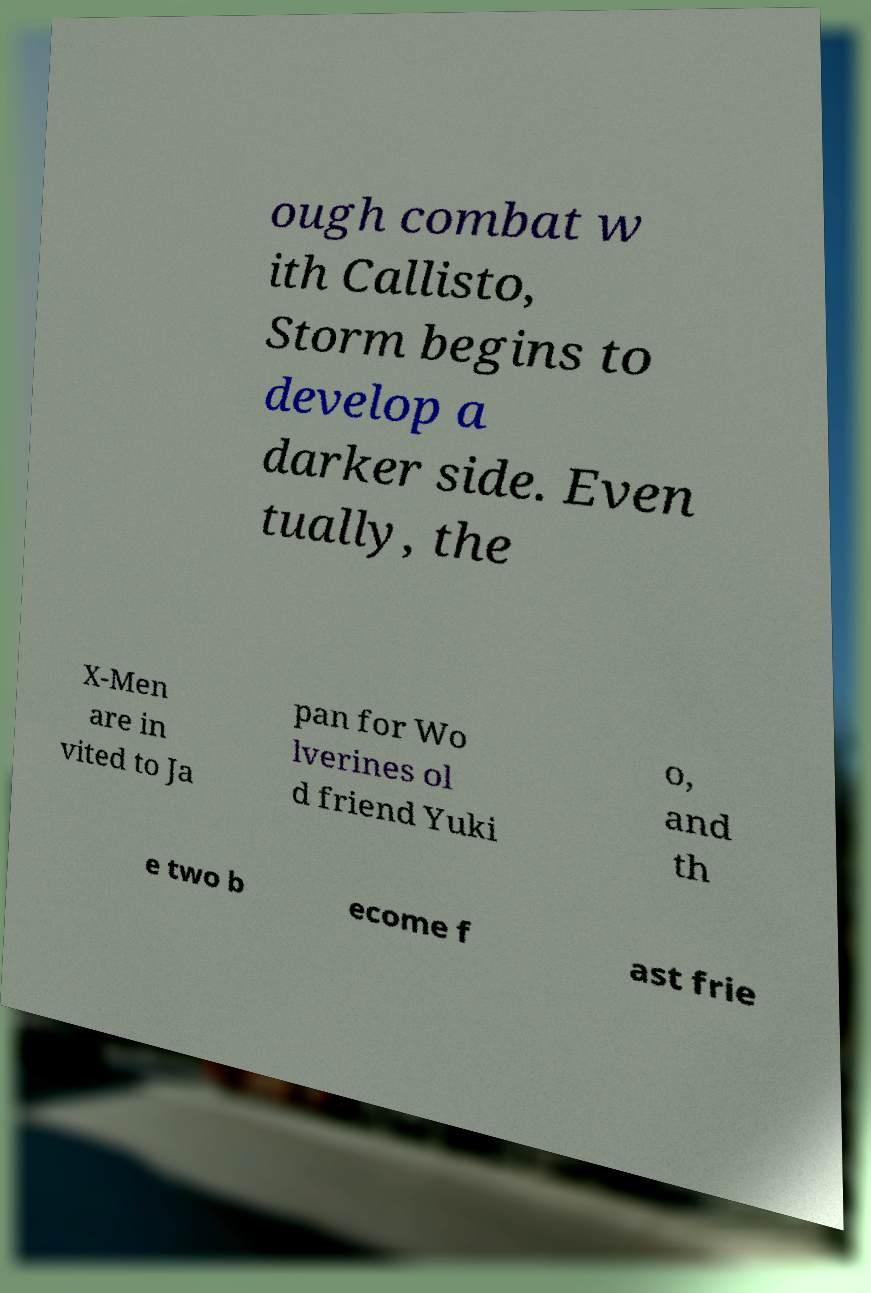What messages or text are displayed in this image? I need them in a readable, typed format. ough combat w ith Callisto, Storm begins to develop a darker side. Even tually, the X-Men are in vited to Ja pan for Wo lverines ol d friend Yuki o, and th e two b ecome f ast frie 